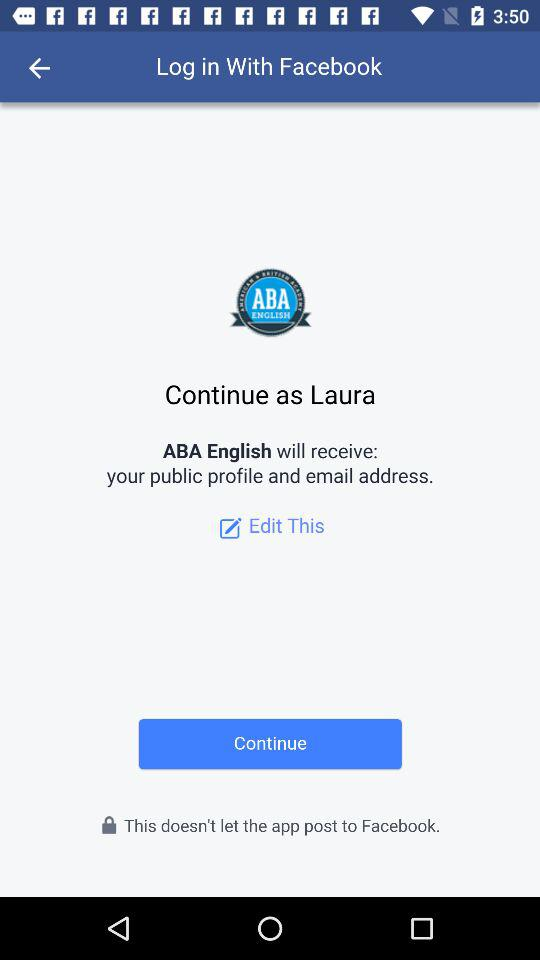What is the user name? The user name is Laura. 